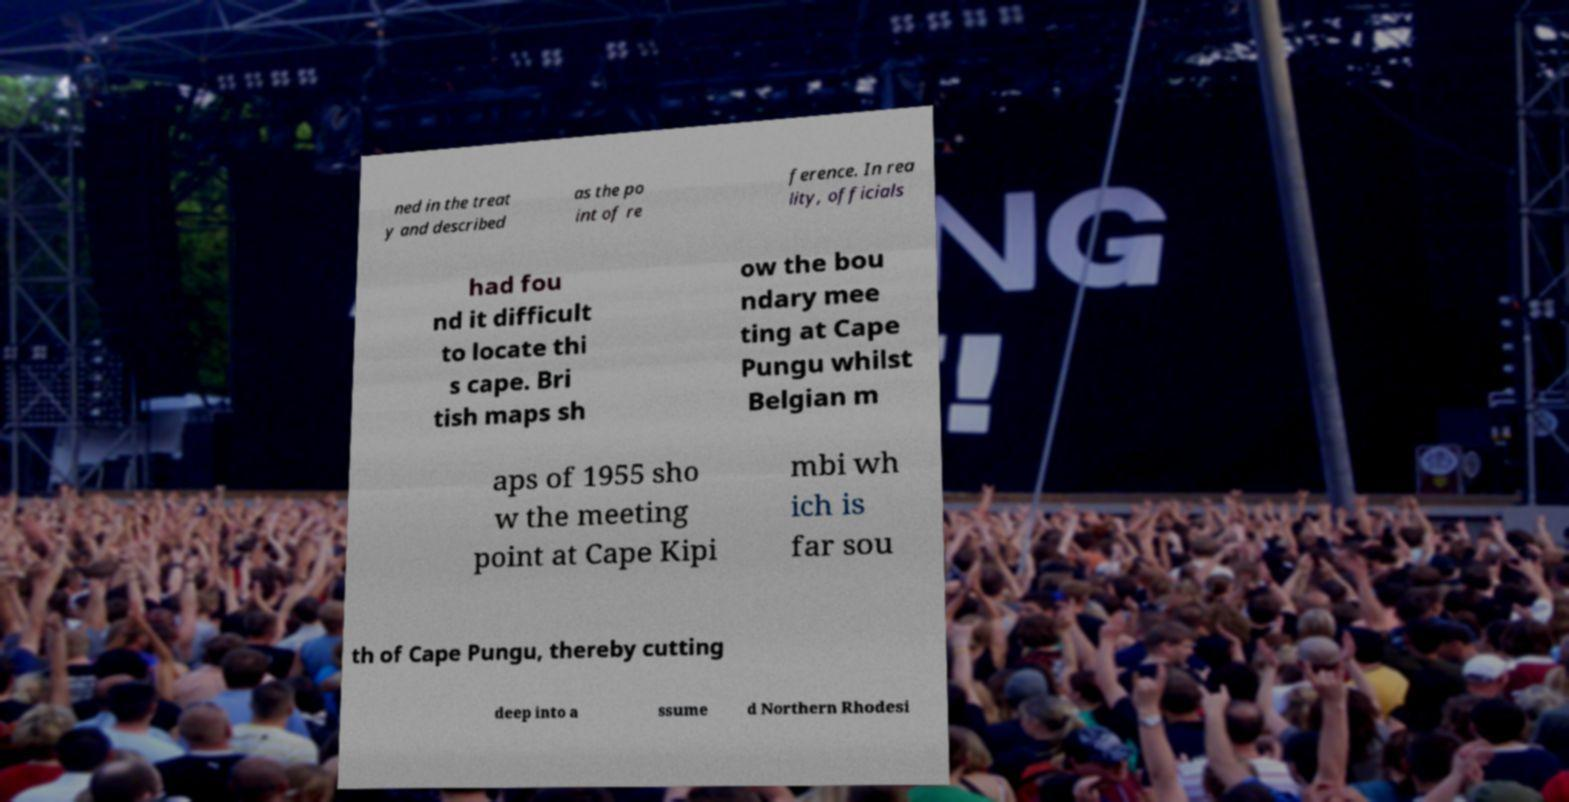Please read and relay the text visible in this image. What does it say? ned in the treat y and described as the po int of re ference. In rea lity, officials had fou nd it difficult to locate thi s cape. Bri tish maps sh ow the bou ndary mee ting at Cape Pungu whilst Belgian m aps of 1955 sho w the meeting point at Cape Kipi mbi wh ich is far sou th of Cape Pungu, thereby cutting deep into a ssume d Northern Rhodesi 